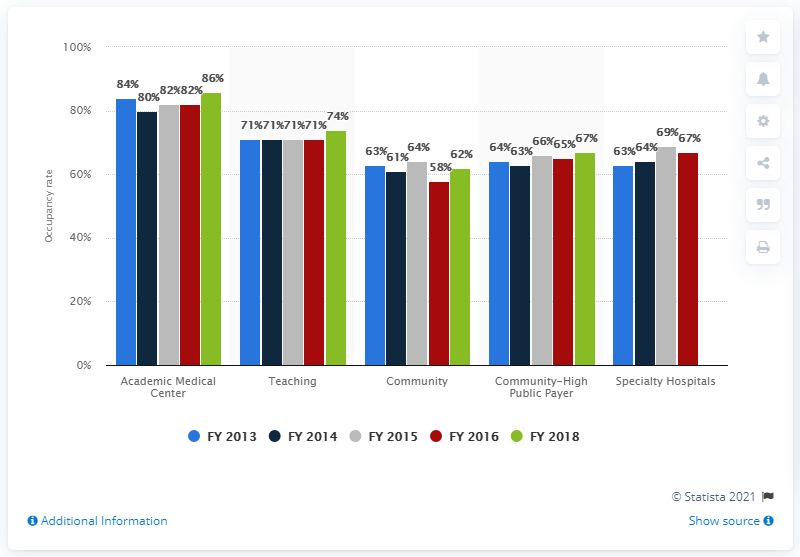Give some essential details in this illustration. The average occupancy rate in teaching positions in all five years is 71.6%. There are five FY data points available in the chart. 